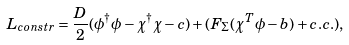<formula> <loc_0><loc_0><loc_500><loc_500>L _ { c o n s t r } = \frac { D } { 2 } ( \phi ^ { \dagger } \phi - \chi ^ { \dagger } \chi - c ) + ( F _ { \Sigma } ( \chi ^ { T } \phi - b ) + c . c . ) ,</formula> 